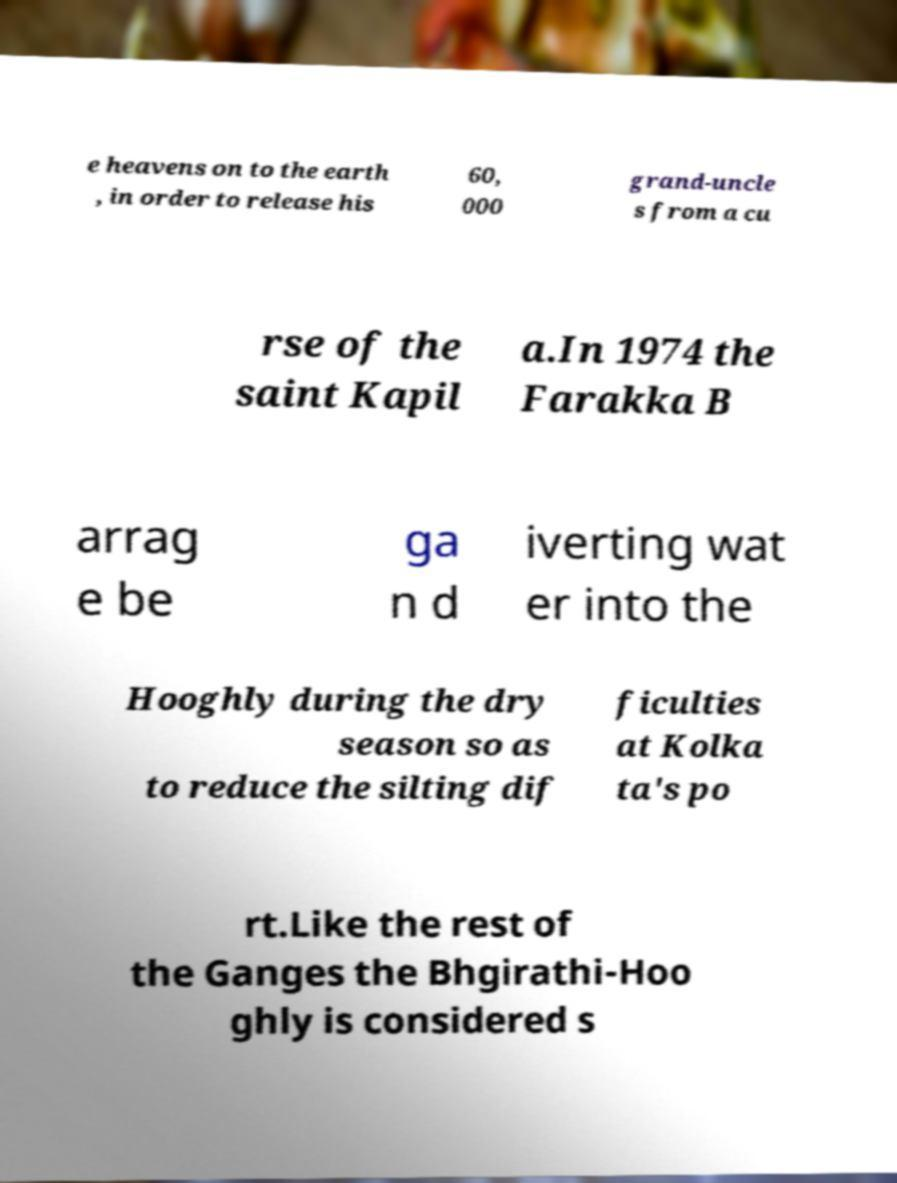Can you read and provide the text displayed in the image?This photo seems to have some interesting text. Can you extract and type it out for me? e heavens on to the earth , in order to release his 60, 000 grand-uncle s from a cu rse of the saint Kapil a.In 1974 the Farakka B arrag e be ga n d iverting wat er into the Hooghly during the dry season so as to reduce the silting dif ficulties at Kolka ta's po rt.Like the rest of the Ganges the Bhgirathi-Hoo ghly is considered s 